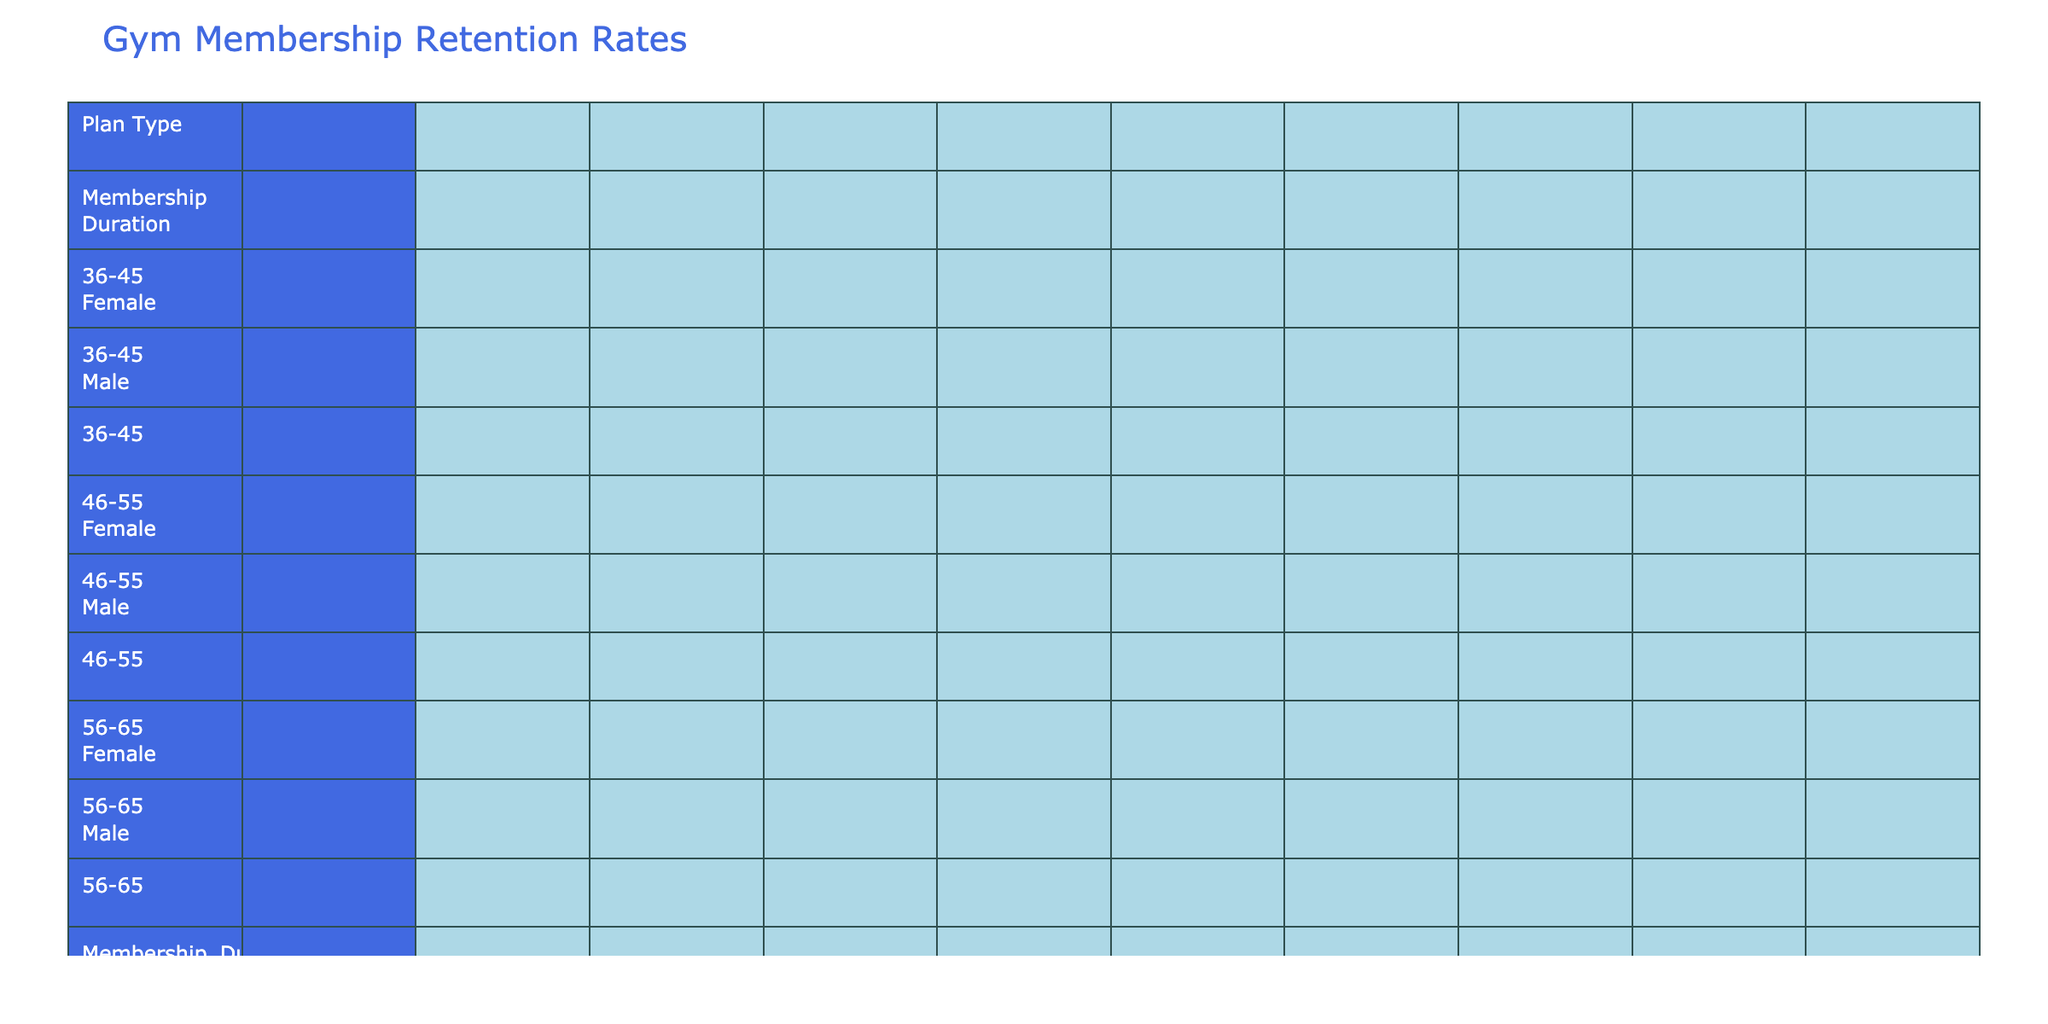What is the retention rate for the Premium plan type among males aged 46-55? From the table, we look for the Premium plan under the age group 46-55. The retention rate listed is 0.89 for Life Time Fitness, which offers a Premium plan.
Answer: 0.89 Which age group has the highest retention rate for the Monthly plan type? We can see the Monthly plan types listed include several age groups. The retention rates for males aged 18-25, females aged 26-35, and others range from 0.55 to 0.68. Among these, the highest retention rate for the Monthly plan is for Anytime Fitness, which shows a retention rate of 0.68 for the 36-45 age group.
Answer: 0.68 Is there a difference in retention rates between the Annual and Quarterly plan types? To answer this, we can average the retention rates for each plan type - for Annual, we have 0.78, 0.76, 0.75, and for Quarterly, we have 0.71, 0.73, and 0.69. The average for Annual is (0.78 + 0.76 + 0.75) / 3 = 0.7667 while that for Quarterly is (0.71 + 0.73 + 0.69) / 3 = 0.7100. So, the Annual plan type has a higher average retention rate.
Answer: Yes, the Annual plan type has a higher average retention rate Which plan type shows the lowest retention rate for females aged 18-25? We look for the relevant entries in the data for females aged 18-25. The Monthly plan from Orange Theory shows a retention rate of 0.59, which is lower than the other recorded rates for females in this age group.
Answer: 0.59 What is the average retention rate for the Family plan type compared to the other plan types? Currently, only the YMCA has a Family plan, with a retention rate of 0.82. To find an average, compare 0.82 with the existing averages for other plan types calculated from their respective rates, but since we only have one Family entry, the average remains at 0.82. Other plan types have different averages but Family appears strong in this context.
Answer: 0.82 